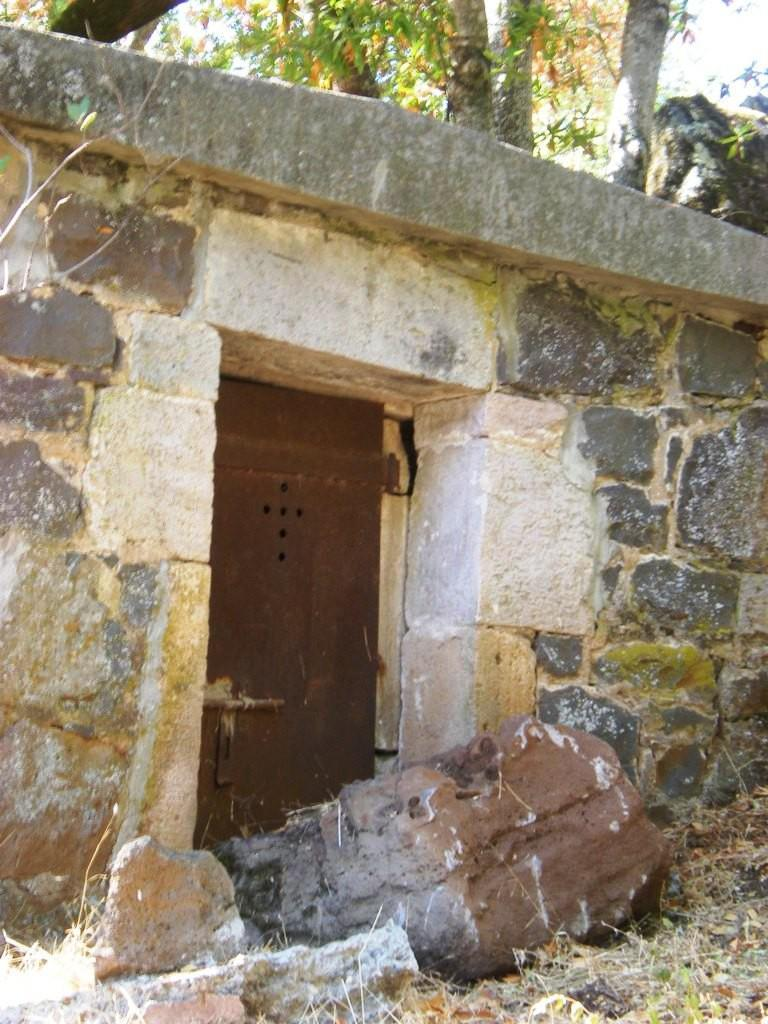What structure can be seen in the image? There is a door in the image. Where is the door located? The door is part of a wall. What can be found at the bottom of the image? There are stones placed on the ground at the bottom of the image. What is visible at the top of the image? There are trees visible at the top of the image. What type of account is mentioned in the image? There is no mention of an account in the image. Can you describe the picture hanging on the wall in the image? There is no picture hanging on the wall in the image; it only shows a door, wall, stones, and trees. 